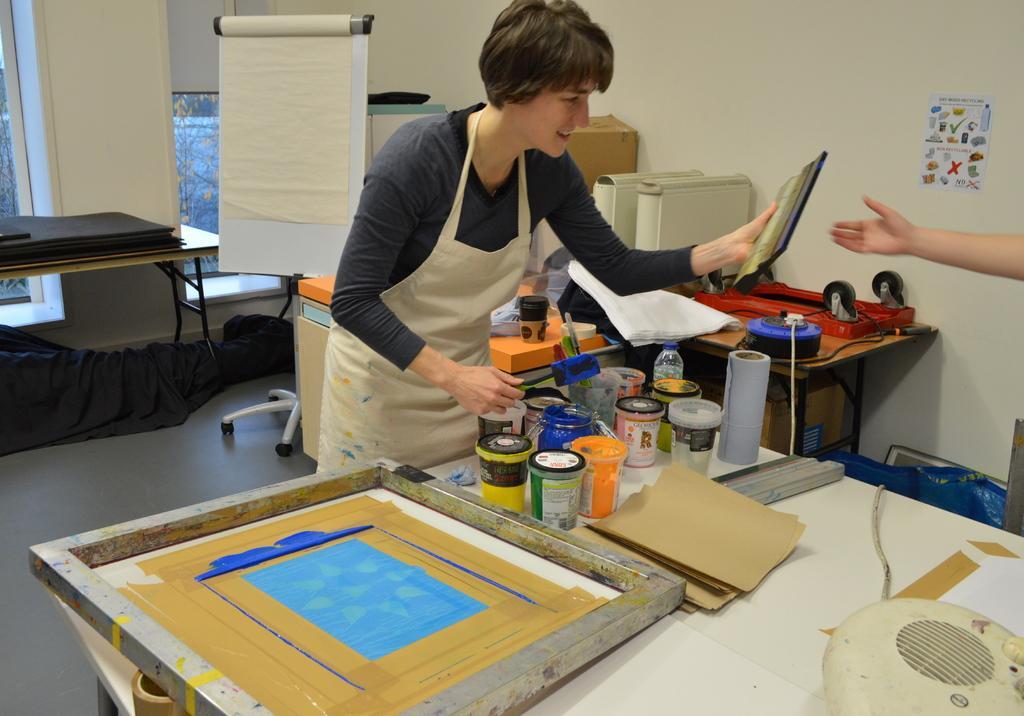Describe this image in one or two sentences. As we can see in the image there is a woman standing on floor. In front of her there is table. On table there are bottles, tissue and there is a cream color wall over here. 